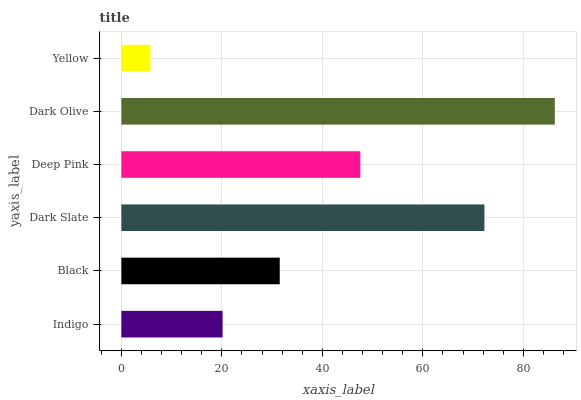Is Yellow the minimum?
Answer yes or no. Yes. Is Dark Olive the maximum?
Answer yes or no. Yes. Is Black the minimum?
Answer yes or no. No. Is Black the maximum?
Answer yes or no. No. Is Black greater than Indigo?
Answer yes or no. Yes. Is Indigo less than Black?
Answer yes or no. Yes. Is Indigo greater than Black?
Answer yes or no. No. Is Black less than Indigo?
Answer yes or no. No. Is Deep Pink the high median?
Answer yes or no. Yes. Is Black the low median?
Answer yes or no. Yes. Is Black the high median?
Answer yes or no. No. Is Indigo the low median?
Answer yes or no. No. 